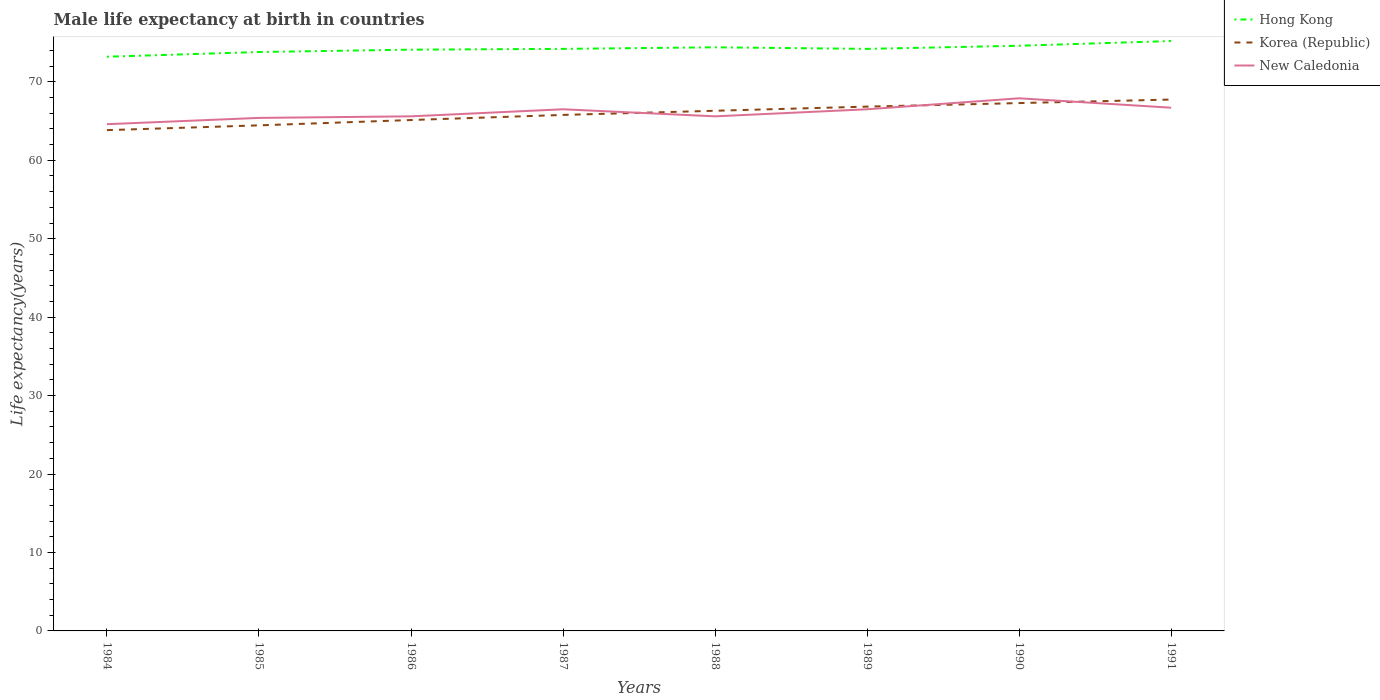How many different coloured lines are there?
Your response must be concise. 3. Across all years, what is the maximum male life expectancy at birth in Korea (Republic)?
Your answer should be very brief. 63.84. In which year was the male life expectancy at birth in New Caledonia maximum?
Your answer should be very brief. 1984. What is the difference between the highest and the second highest male life expectancy at birth in Hong Kong?
Offer a terse response. 2. What is the difference between the highest and the lowest male life expectancy at birth in Korea (Republic)?
Your answer should be compact. 4. Is the male life expectancy at birth in Korea (Republic) strictly greater than the male life expectancy at birth in New Caledonia over the years?
Provide a short and direct response. No. Does the graph contain any zero values?
Give a very brief answer. No. Does the graph contain grids?
Make the answer very short. No. How many legend labels are there?
Keep it short and to the point. 3. What is the title of the graph?
Provide a short and direct response. Male life expectancy at birth in countries. What is the label or title of the Y-axis?
Ensure brevity in your answer.  Life expectancy(years). What is the Life expectancy(years) in Hong Kong in 1984?
Offer a terse response. 73.2. What is the Life expectancy(years) in Korea (Republic) in 1984?
Make the answer very short. 63.84. What is the Life expectancy(years) of New Caledonia in 1984?
Your response must be concise. 64.6. What is the Life expectancy(years) in Hong Kong in 1985?
Ensure brevity in your answer.  73.8. What is the Life expectancy(years) of Korea (Republic) in 1985?
Your answer should be very brief. 64.45. What is the Life expectancy(years) in New Caledonia in 1985?
Make the answer very short. 65.4. What is the Life expectancy(years) in Hong Kong in 1986?
Provide a short and direct response. 74.1. What is the Life expectancy(years) in Korea (Republic) in 1986?
Offer a terse response. 65.13. What is the Life expectancy(years) of New Caledonia in 1986?
Your response must be concise. 65.6. What is the Life expectancy(years) of Hong Kong in 1987?
Offer a terse response. 74.2. What is the Life expectancy(years) in Korea (Republic) in 1987?
Offer a very short reply. 65.78. What is the Life expectancy(years) in New Caledonia in 1987?
Keep it short and to the point. 66.5. What is the Life expectancy(years) in Hong Kong in 1988?
Ensure brevity in your answer.  74.4. What is the Life expectancy(years) in Korea (Republic) in 1988?
Offer a terse response. 66.31. What is the Life expectancy(years) of New Caledonia in 1988?
Offer a very short reply. 65.6. What is the Life expectancy(years) of Hong Kong in 1989?
Give a very brief answer. 74.2. What is the Life expectancy(years) of Korea (Republic) in 1989?
Provide a succinct answer. 66.84. What is the Life expectancy(years) in New Caledonia in 1989?
Offer a very short reply. 66.5. What is the Life expectancy(years) of Hong Kong in 1990?
Give a very brief answer. 74.6. What is the Life expectancy(years) of Korea (Republic) in 1990?
Your response must be concise. 67.29. What is the Life expectancy(years) of New Caledonia in 1990?
Your response must be concise. 67.9. What is the Life expectancy(years) of Hong Kong in 1991?
Offer a terse response. 75.2. What is the Life expectancy(years) in Korea (Republic) in 1991?
Your answer should be very brief. 67.74. What is the Life expectancy(years) in New Caledonia in 1991?
Keep it short and to the point. 66.7. Across all years, what is the maximum Life expectancy(years) of Hong Kong?
Give a very brief answer. 75.2. Across all years, what is the maximum Life expectancy(years) of Korea (Republic)?
Provide a succinct answer. 67.74. Across all years, what is the maximum Life expectancy(years) of New Caledonia?
Offer a terse response. 67.9. Across all years, what is the minimum Life expectancy(years) in Hong Kong?
Keep it short and to the point. 73.2. Across all years, what is the minimum Life expectancy(years) in Korea (Republic)?
Provide a short and direct response. 63.84. Across all years, what is the minimum Life expectancy(years) of New Caledonia?
Provide a short and direct response. 64.6. What is the total Life expectancy(years) in Hong Kong in the graph?
Provide a short and direct response. 593.7. What is the total Life expectancy(years) of Korea (Republic) in the graph?
Offer a terse response. 527.38. What is the total Life expectancy(years) of New Caledonia in the graph?
Keep it short and to the point. 528.8. What is the difference between the Life expectancy(years) in Hong Kong in 1984 and that in 1985?
Provide a succinct answer. -0.6. What is the difference between the Life expectancy(years) of Korea (Republic) in 1984 and that in 1985?
Offer a very short reply. -0.61. What is the difference between the Life expectancy(years) in New Caledonia in 1984 and that in 1985?
Ensure brevity in your answer.  -0.8. What is the difference between the Life expectancy(years) in Korea (Republic) in 1984 and that in 1986?
Your answer should be compact. -1.29. What is the difference between the Life expectancy(years) in Hong Kong in 1984 and that in 1987?
Your answer should be very brief. -1. What is the difference between the Life expectancy(years) in Korea (Republic) in 1984 and that in 1987?
Ensure brevity in your answer.  -1.94. What is the difference between the Life expectancy(years) of Korea (Republic) in 1984 and that in 1988?
Make the answer very short. -2.47. What is the difference between the Life expectancy(years) of Hong Kong in 1984 and that in 1989?
Your response must be concise. -1. What is the difference between the Life expectancy(years) in Korea (Republic) in 1984 and that in 1989?
Give a very brief answer. -3. What is the difference between the Life expectancy(years) of New Caledonia in 1984 and that in 1989?
Offer a very short reply. -1.9. What is the difference between the Life expectancy(years) in Hong Kong in 1984 and that in 1990?
Make the answer very short. -1.4. What is the difference between the Life expectancy(years) in Korea (Republic) in 1984 and that in 1990?
Provide a short and direct response. -3.45. What is the difference between the Life expectancy(years) of Hong Kong in 1984 and that in 1991?
Give a very brief answer. -2. What is the difference between the Life expectancy(years) in Korea (Republic) in 1984 and that in 1991?
Your response must be concise. -3.9. What is the difference between the Life expectancy(years) in New Caledonia in 1984 and that in 1991?
Provide a succinct answer. -2.1. What is the difference between the Life expectancy(years) in Korea (Republic) in 1985 and that in 1986?
Your response must be concise. -0.68. What is the difference between the Life expectancy(years) in Korea (Republic) in 1985 and that in 1987?
Your answer should be very brief. -1.33. What is the difference between the Life expectancy(years) in Hong Kong in 1985 and that in 1988?
Keep it short and to the point. -0.6. What is the difference between the Life expectancy(years) in Korea (Republic) in 1985 and that in 1988?
Make the answer very short. -1.86. What is the difference between the Life expectancy(years) of Korea (Republic) in 1985 and that in 1989?
Offer a very short reply. -2.39. What is the difference between the Life expectancy(years) of Hong Kong in 1985 and that in 1990?
Your answer should be very brief. -0.8. What is the difference between the Life expectancy(years) of Korea (Republic) in 1985 and that in 1990?
Provide a short and direct response. -2.84. What is the difference between the Life expectancy(years) of Hong Kong in 1985 and that in 1991?
Provide a succinct answer. -1.4. What is the difference between the Life expectancy(years) in Korea (Republic) in 1985 and that in 1991?
Provide a short and direct response. -3.29. What is the difference between the Life expectancy(years) of Korea (Republic) in 1986 and that in 1987?
Your response must be concise. -0.65. What is the difference between the Life expectancy(years) in New Caledonia in 1986 and that in 1987?
Your answer should be very brief. -0.9. What is the difference between the Life expectancy(years) in Hong Kong in 1986 and that in 1988?
Your answer should be very brief. -0.3. What is the difference between the Life expectancy(years) in Korea (Republic) in 1986 and that in 1988?
Offer a terse response. -1.18. What is the difference between the Life expectancy(years) of New Caledonia in 1986 and that in 1988?
Keep it short and to the point. 0. What is the difference between the Life expectancy(years) in Korea (Republic) in 1986 and that in 1989?
Keep it short and to the point. -1.71. What is the difference between the Life expectancy(years) of Korea (Republic) in 1986 and that in 1990?
Provide a short and direct response. -2.16. What is the difference between the Life expectancy(years) in Korea (Republic) in 1986 and that in 1991?
Ensure brevity in your answer.  -2.61. What is the difference between the Life expectancy(years) of New Caledonia in 1986 and that in 1991?
Provide a succinct answer. -1.1. What is the difference between the Life expectancy(years) of Hong Kong in 1987 and that in 1988?
Provide a short and direct response. -0.2. What is the difference between the Life expectancy(years) in Korea (Republic) in 1987 and that in 1988?
Provide a succinct answer. -0.53. What is the difference between the Life expectancy(years) in Korea (Republic) in 1987 and that in 1989?
Give a very brief answer. -1.06. What is the difference between the Life expectancy(years) in Korea (Republic) in 1987 and that in 1990?
Offer a very short reply. -1.51. What is the difference between the Life expectancy(years) in Hong Kong in 1987 and that in 1991?
Your answer should be very brief. -1. What is the difference between the Life expectancy(years) of Korea (Republic) in 1987 and that in 1991?
Your answer should be very brief. -1.96. What is the difference between the Life expectancy(years) in New Caledonia in 1987 and that in 1991?
Give a very brief answer. -0.2. What is the difference between the Life expectancy(years) of Korea (Republic) in 1988 and that in 1989?
Provide a succinct answer. -0.53. What is the difference between the Life expectancy(years) of Hong Kong in 1988 and that in 1990?
Your answer should be very brief. -0.2. What is the difference between the Life expectancy(years) of Korea (Republic) in 1988 and that in 1990?
Offer a terse response. -0.98. What is the difference between the Life expectancy(years) of Korea (Republic) in 1988 and that in 1991?
Ensure brevity in your answer.  -1.43. What is the difference between the Life expectancy(years) in Hong Kong in 1989 and that in 1990?
Your answer should be compact. -0.4. What is the difference between the Life expectancy(years) in Korea (Republic) in 1989 and that in 1990?
Your response must be concise. -0.45. What is the difference between the Life expectancy(years) of New Caledonia in 1989 and that in 1990?
Make the answer very short. -1.4. What is the difference between the Life expectancy(years) of Hong Kong in 1989 and that in 1991?
Your response must be concise. -1. What is the difference between the Life expectancy(years) in Korea (Republic) in 1990 and that in 1991?
Make the answer very short. -0.45. What is the difference between the Life expectancy(years) in New Caledonia in 1990 and that in 1991?
Give a very brief answer. 1.2. What is the difference between the Life expectancy(years) in Hong Kong in 1984 and the Life expectancy(years) in Korea (Republic) in 1985?
Provide a short and direct response. 8.75. What is the difference between the Life expectancy(years) in Korea (Republic) in 1984 and the Life expectancy(years) in New Caledonia in 1985?
Offer a very short reply. -1.56. What is the difference between the Life expectancy(years) of Hong Kong in 1984 and the Life expectancy(years) of Korea (Republic) in 1986?
Give a very brief answer. 8.07. What is the difference between the Life expectancy(years) of Hong Kong in 1984 and the Life expectancy(years) of New Caledonia in 1986?
Give a very brief answer. 7.6. What is the difference between the Life expectancy(years) in Korea (Republic) in 1984 and the Life expectancy(years) in New Caledonia in 1986?
Offer a very short reply. -1.76. What is the difference between the Life expectancy(years) in Hong Kong in 1984 and the Life expectancy(years) in Korea (Republic) in 1987?
Offer a terse response. 7.42. What is the difference between the Life expectancy(years) in Hong Kong in 1984 and the Life expectancy(years) in New Caledonia in 1987?
Offer a very short reply. 6.7. What is the difference between the Life expectancy(years) in Korea (Republic) in 1984 and the Life expectancy(years) in New Caledonia in 1987?
Keep it short and to the point. -2.66. What is the difference between the Life expectancy(years) in Hong Kong in 1984 and the Life expectancy(years) in Korea (Republic) in 1988?
Ensure brevity in your answer.  6.89. What is the difference between the Life expectancy(years) of Hong Kong in 1984 and the Life expectancy(years) of New Caledonia in 1988?
Provide a short and direct response. 7.6. What is the difference between the Life expectancy(years) of Korea (Republic) in 1984 and the Life expectancy(years) of New Caledonia in 1988?
Provide a short and direct response. -1.76. What is the difference between the Life expectancy(years) in Hong Kong in 1984 and the Life expectancy(years) in Korea (Republic) in 1989?
Offer a very short reply. 6.36. What is the difference between the Life expectancy(years) of Hong Kong in 1984 and the Life expectancy(years) of New Caledonia in 1989?
Give a very brief answer. 6.7. What is the difference between the Life expectancy(years) in Korea (Republic) in 1984 and the Life expectancy(years) in New Caledonia in 1989?
Your answer should be very brief. -2.66. What is the difference between the Life expectancy(years) in Hong Kong in 1984 and the Life expectancy(years) in Korea (Republic) in 1990?
Make the answer very short. 5.91. What is the difference between the Life expectancy(years) of Korea (Republic) in 1984 and the Life expectancy(years) of New Caledonia in 1990?
Make the answer very short. -4.06. What is the difference between the Life expectancy(years) of Hong Kong in 1984 and the Life expectancy(years) of Korea (Republic) in 1991?
Make the answer very short. 5.46. What is the difference between the Life expectancy(years) of Korea (Republic) in 1984 and the Life expectancy(years) of New Caledonia in 1991?
Offer a terse response. -2.86. What is the difference between the Life expectancy(years) in Hong Kong in 1985 and the Life expectancy(years) in Korea (Republic) in 1986?
Offer a terse response. 8.67. What is the difference between the Life expectancy(years) in Korea (Republic) in 1985 and the Life expectancy(years) in New Caledonia in 1986?
Provide a short and direct response. -1.15. What is the difference between the Life expectancy(years) in Hong Kong in 1985 and the Life expectancy(years) in Korea (Republic) in 1987?
Make the answer very short. 8.02. What is the difference between the Life expectancy(years) in Hong Kong in 1985 and the Life expectancy(years) in New Caledonia in 1987?
Give a very brief answer. 7.3. What is the difference between the Life expectancy(years) of Korea (Republic) in 1985 and the Life expectancy(years) of New Caledonia in 1987?
Give a very brief answer. -2.05. What is the difference between the Life expectancy(years) in Hong Kong in 1985 and the Life expectancy(years) in Korea (Republic) in 1988?
Make the answer very short. 7.49. What is the difference between the Life expectancy(years) in Hong Kong in 1985 and the Life expectancy(years) in New Caledonia in 1988?
Keep it short and to the point. 8.2. What is the difference between the Life expectancy(years) in Korea (Republic) in 1985 and the Life expectancy(years) in New Caledonia in 1988?
Offer a very short reply. -1.15. What is the difference between the Life expectancy(years) in Hong Kong in 1985 and the Life expectancy(years) in Korea (Republic) in 1989?
Keep it short and to the point. 6.96. What is the difference between the Life expectancy(years) in Korea (Republic) in 1985 and the Life expectancy(years) in New Caledonia in 1989?
Make the answer very short. -2.05. What is the difference between the Life expectancy(years) in Hong Kong in 1985 and the Life expectancy(years) in Korea (Republic) in 1990?
Your response must be concise. 6.51. What is the difference between the Life expectancy(years) in Korea (Republic) in 1985 and the Life expectancy(years) in New Caledonia in 1990?
Give a very brief answer. -3.45. What is the difference between the Life expectancy(years) in Hong Kong in 1985 and the Life expectancy(years) in Korea (Republic) in 1991?
Offer a terse response. 6.06. What is the difference between the Life expectancy(years) in Hong Kong in 1985 and the Life expectancy(years) in New Caledonia in 1991?
Provide a short and direct response. 7.1. What is the difference between the Life expectancy(years) in Korea (Republic) in 1985 and the Life expectancy(years) in New Caledonia in 1991?
Your answer should be very brief. -2.25. What is the difference between the Life expectancy(years) in Hong Kong in 1986 and the Life expectancy(years) in Korea (Republic) in 1987?
Provide a succinct answer. 8.32. What is the difference between the Life expectancy(years) of Korea (Republic) in 1986 and the Life expectancy(years) of New Caledonia in 1987?
Your answer should be very brief. -1.37. What is the difference between the Life expectancy(years) in Hong Kong in 1986 and the Life expectancy(years) in Korea (Republic) in 1988?
Provide a succinct answer. 7.79. What is the difference between the Life expectancy(years) in Korea (Republic) in 1986 and the Life expectancy(years) in New Caledonia in 1988?
Your answer should be very brief. -0.47. What is the difference between the Life expectancy(years) in Hong Kong in 1986 and the Life expectancy(years) in Korea (Republic) in 1989?
Ensure brevity in your answer.  7.26. What is the difference between the Life expectancy(years) in Korea (Republic) in 1986 and the Life expectancy(years) in New Caledonia in 1989?
Give a very brief answer. -1.37. What is the difference between the Life expectancy(years) of Hong Kong in 1986 and the Life expectancy(years) of Korea (Republic) in 1990?
Your answer should be very brief. 6.81. What is the difference between the Life expectancy(years) in Hong Kong in 1986 and the Life expectancy(years) in New Caledonia in 1990?
Offer a very short reply. 6.2. What is the difference between the Life expectancy(years) in Korea (Republic) in 1986 and the Life expectancy(years) in New Caledonia in 1990?
Provide a short and direct response. -2.77. What is the difference between the Life expectancy(years) of Hong Kong in 1986 and the Life expectancy(years) of Korea (Republic) in 1991?
Your answer should be very brief. 6.36. What is the difference between the Life expectancy(years) in Korea (Republic) in 1986 and the Life expectancy(years) in New Caledonia in 1991?
Provide a short and direct response. -1.57. What is the difference between the Life expectancy(years) of Hong Kong in 1987 and the Life expectancy(years) of Korea (Republic) in 1988?
Provide a succinct answer. 7.89. What is the difference between the Life expectancy(years) of Korea (Republic) in 1987 and the Life expectancy(years) of New Caledonia in 1988?
Provide a short and direct response. 0.18. What is the difference between the Life expectancy(years) in Hong Kong in 1987 and the Life expectancy(years) in Korea (Republic) in 1989?
Your response must be concise. 7.36. What is the difference between the Life expectancy(years) of Hong Kong in 1987 and the Life expectancy(years) of New Caledonia in 1989?
Offer a very short reply. 7.7. What is the difference between the Life expectancy(years) of Korea (Republic) in 1987 and the Life expectancy(years) of New Caledonia in 1989?
Your answer should be very brief. -0.72. What is the difference between the Life expectancy(years) of Hong Kong in 1987 and the Life expectancy(years) of Korea (Republic) in 1990?
Ensure brevity in your answer.  6.91. What is the difference between the Life expectancy(years) in Korea (Republic) in 1987 and the Life expectancy(years) in New Caledonia in 1990?
Your answer should be compact. -2.12. What is the difference between the Life expectancy(years) in Hong Kong in 1987 and the Life expectancy(years) in Korea (Republic) in 1991?
Provide a succinct answer. 6.46. What is the difference between the Life expectancy(years) of Korea (Republic) in 1987 and the Life expectancy(years) of New Caledonia in 1991?
Keep it short and to the point. -0.92. What is the difference between the Life expectancy(years) in Hong Kong in 1988 and the Life expectancy(years) in Korea (Republic) in 1989?
Offer a very short reply. 7.56. What is the difference between the Life expectancy(years) of Korea (Republic) in 1988 and the Life expectancy(years) of New Caledonia in 1989?
Your answer should be very brief. -0.19. What is the difference between the Life expectancy(years) of Hong Kong in 1988 and the Life expectancy(years) of Korea (Republic) in 1990?
Provide a succinct answer. 7.11. What is the difference between the Life expectancy(years) of Hong Kong in 1988 and the Life expectancy(years) of New Caledonia in 1990?
Keep it short and to the point. 6.5. What is the difference between the Life expectancy(years) of Korea (Republic) in 1988 and the Life expectancy(years) of New Caledonia in 1990?
Provide a short and direct response. -1.59. What is the difference between the Life expectancy(years) in Hong Kong in 1988 and the Life expectancy(years) in Korea (Republic) in 1991?
Keep it short and to the point. 6.66. What is the difference between the Life expectancy(years) of Korea (Republic) in 1988 and the Life expectancy(years) of New Caledonia in 1991?
Ensure brevity in your answer.  -0.39. What is the difference between the Life expectancy(years) in Hong Kong in 1989 and the Life expectancy(years) in Korea (Republic) in 1990?
Keep it short and to the point. 6.91. What is the difference between the Life expectancy(years) of Hong Kong in 1989 and the Life expectancy(years) of New Caledonia in 1990?
Offer a terse response. 6.3. What is the difference between the Life expectancy(years) of Korea (Republic) in 1989 and the Life expectancy(years) of New Caledonia in 1990?
Your answer should be compact. -1.06. What is the difference between the Life expectancy(years) in Hong Kong in 1989 and the Life expectancy(years) in Korea (Republic) in 1991?
Provide a succinct answer. 6.46. What is the difference between the Life expectancy(years) of Hong Kong in 1989 and the Life expectancy(years) of New Caledonia in 1991?
Keep it short and to the point. 7.5. What is the difference between the Life expectancy(years) of Korea (Republic) in 1989 and the Life expectancy(years) of New Caledonia in 1991?
Provide a succinct answer. 0.14. What is the difference between the Life expectancy(years) in Hong Kong in 1990 and the Life expectancy(years) in Korea (Republic) in 1991?
Offer a very short reply. 6.86. What is the difference between the Life expectancy(years) of Hong Kong in 1990 and the Life expectancy(years) of New Caledonia in 1991?
Your response must be concise. 7.9. What is the difference between the Life expectancy(years) of Korea (Republic) in 1990 and the Life expectancy(years) of New Caledonia in 1991?
Provide a short and direct response. 0.59. What is the average Life expectancy(years) in Hong Kong per year?
Ensure brevity in your answer.  74.21. What is the average Life expectancy(years) of Korea (Republic) per year?
Keep it short and to the point. 65.92. What is the average Life expectancy(years) of New Caledonia per year?
Your response must be concise. 66.1. In the year 1984, what is the difference between the Life expectancy(years) of Hong Kong and Life expectancy(years) of Korea (Republic)?
Ensure brevity in your answer.  9.36. In the year 1984, what is the difference between the Life expectancy(years) in Hong Kong and Life expectancy(years) in New Caledonia?
Offer a terse response. 8.6. In the year 1984, what is the difference between the Life expectancy(years) of Korea (Republic) and Life expectancy(years) of New Caledonia?
Ensure brevity in your answer.  -0.76. In the year 1985, what is the difference between the Life expectancy(years) in Hong Kong and Life expectancy(years) in Korea (Republic)?
Keep it short and to the point. 9.35. In the year 1985, what is the difference between the Life expectancy(years) in Korea (Republic) and Life expectancy(years) in New Caledonia?
Offer a very short reply. -0.95. In the year 1986, what is the difference between the Life expectancy(years) in Hong Kong and Life expectancy(years) in Korea (Republic)?
Provide a short and direct response. 8.97. In the year 1986, what is the difference between the Life expectancy(years) in Korea (Republic) and Life expectancy(years) in New Caledonia?
Make the answer very short. -0.47. In the year 1987, what is the difference between the Life expectancy(years) in Hong Kong and Life expectancy(years) in Korea (Republic)?
Give a very brief answer. 8.42. In the year 1987, what is the difference between the Life expectancy(years) in Hong Kong and Life expectancy(years) in New Caledonia?
Provide a succinct answer. 7.7. In the year 1987, what is the difference between the Life expectancy(years) of Korea (Republic) and Life expectancy(years) of New Caledonia?
Keep it short and to the point. -0.72. In the year 1988, what is the difference between the Life expectancy(years) of Hong Kong and Life expectancy(years) of Korea (Republic)?
Give a very brief answer. 8.09. In the year 1988, what is the difference between the Life expectancy(years) in Hong Kong and Life expectancy(years) in New Caledonia?
Offer a very short reply. 8.8. In the year 1988, what is the difference between the Life expectancy(years) of Korea (Republic) and Life expectancy(years) of New Caledonia?
Give a very brief answer. 0.71. In the year 1989, what is the difference between the Life expectancy(years) of Hong Kong and Life expectancy(years) of Korea (Republic)?
Provide a succinct answer. 7.36. In the year 1989, what is the difference between the Life expectancy(years) in Hong Kong and Life expectancy(years) in New Caledonia?
Offer a very short reply. 7.7. In the year 1989, what is the difference between the Life expectancy(years) of Korea (Republic) and Life expectancy(years) of New Caledonia?
Make the answer very short. 0.34. In the year 1990, what is the difference between the Life expectancy(years) of Hong Kong and Life expectancy(years) of Korea (Republic)?
Your response must be concise. 7.31. In the year 1990, what is the difference between the Life expectancy(years) of Hong Kong and Life expectancy(years) of New Caledonia?
Ensure brevity in your answer.  6.7. In the year 1990, what is the difference between the Life expectancy(years) in Korea (Republic) and Life expectancy(years) in New Caledonia?
Ensure brevity in your answer.  -0.61. In the year 1991, what is the difference between the Life expectancy(years) of Hong Kong and Life expectancy(years) of Korea (Republic)?
Offer a very short reply. 7.46. In the year 1991, what is the difference between the Life expectancy(years) of Hong Kong and Life expectancy(years) of New Caledonia?
Offer a terse response. 8.5. In the year 1991, what is the difference between the Life expectancy(years) of Korea (Republic) and Life expectancy(years) of New Caledonia?
Give a very brief answer. 1.04. What is the ratio of the Life expectancy(years) in Hong Kong in 1984 to that in 1986?
Your answer should be very brief. 0.99. What is the ratio of the Life expectancy(years) of Korea (Republic) in 1984 to that in 1986?
Offer a terse response. 0.98. What is the ratio of the Life expectancy(years) of New Caledonia in 1984 to that in 1986?
Your answer should be compact. 0.98. What is the ratio of the Life expectancy(years) of Hong Kong in 1984 to that in 1987?
Provide a short and direct response. 0.99. What is the ratio of the Life expectancy(years) in Korea (Republic) in 1984 to that in 1987?
Make the answer very short. 0.97. What is the ratio of the Life expectancy(years) of New Caledonia in 1984 to that in 1987?
Your response must be concise. 0.97. What is the ratio of the Life expectancy(years) of Hong Kong in 1984 to that in 1988?
Your response must be concise. 0.98. What is the ratio of the Life expectancy(years) of Korea (Republic) in 1984 to that in 1988?
Keep it short and to the point. 0.96. What is the ratio of the Life expectancy(years) of Hong Kong in 1984 to that in 1989?
Make the answer very short. 0.99. What is the ratio of the Life expectancy(years) of Korea (Republic) in 1984 to that in 1989?
Your answer should be very brief. 0.96. What is the ratio of the Life expectancy(years) of New Caledonia in 1984 to that in 1989?
Your response must be concise. 0.97. What is the ratio of the Life expectancy(years) of Hong Kong in 1984 to that in 1990?
Provide a short and direct response. 0.98. What is the ratio of the Life expectancy(years) in Korea (Republic) in 1984 to that in 1990?
Your answer should be compact. 0.95. What is the ratio of the Life expectancy(years) in New Caledonia in 1984 to that in 1990?
Ensure brevity in your answer.  0.95. What is the ratio of the Life expectancy(years) in Hong Kong in 1984 to that in 1991?
Your answer should be very brief. 0.97. What is the ratio of the Life expectancy(years) of Korea (Republic) in 1984 to that in 1991?
Provide a short and direct response. 0.94. What is the ratio of the Life expectancy(years) in New Caledonia in 1984 to that in 1991?
Provide a short and direct response. 0.97. What is the ratio of the Life expectancy(years) in Korea (Republic) in 1985 to that in 1986?
Provide a succinct answer. 0.99. What is the ratio of the Life expectancy(years) of New Caledonia in 1985 to that in 1986?
Keep it short and to the point. 1. What is the ratio of the Life expectancy(years) of Korea (Republic) in 1985 to that in 1987?
Ensure brevity in your answer.  0.98. What is the ratio of the Life expectancy(years) in New Caledonia in 1985 to that in 1987?
Give a very brief answer. 0.98. What is the ratio of the Life expectancy(years) of Hong Kong in 1985 to that in 1988?
Your answer should be compact. 0.99. What is the ratio of the Life expectancy(years) of Korea (Republic) in 1985 to that in 1988?
Offer a very short reply. 0.97. What is the ratio of the Life expectancy(years) of Hong Kong in 1985 to that in 1989?
Provide a succinct answer. 0.99. What is the ratio of the Life expectancy(years) of Korea (Republic) in 1985 to that in 1989?
Provide a succinct answer. 0.96. What is the ratio of the Life expectancy(years) in New Caledonia in 1985 to that in 1989?
Keep it short and to the point. 0.98. What is the ratio of the Life expectancy(years) of Hong Kong in 1985 to that in 1990?
Your answer should be very brief. 0.99. What is the ratio of the Life expectancy(years) in Korea (Republic) in 1985 to that in 1990?
Provide a short and direct response. 0.96. What is the ratio of the Life expectancy(years) in New Caledonia in 1985 to that in 1990?
Keep it short and to the point. 0.96. What is the ratio of the Life expectancy(years) in Hong Kong in 1985 to that in 1991?
Your answer should be compact. 0.98. What is the ratio of the Life expectancy(years) of Korea (Republic) in 1985 to that in 1991?
Offer a terse response. 0.95. What is the ratio of the Life expectancy(years) in New Caledonia in 1985 to that in 1991?
Your response must be concise. 0.98. What is the ratio of the Life expectancy(years) in New Caledonia in 1986 to that in 1987?
Provide a succinct answer. 0.99. What is the ratio of the Life expectancy(years) in Korea (Republic) in 1986 to that in 1988?
Provide a short and direct response. 0.98. What is the ratio of the Life expectancy(years) in Korea (Republic) in 1986 to that in 1989?
Your response must be concise. 0.97. What is the ratio of the Life expectancy(years) in New Caledonia in 1986 to that in 1989?
Offer a very short reply. 0.99. What is the ratio of the Life expectancy(years) of Hong Kong in 1986 to that in 1990?
Provide a succinct answer. 0.99. What is the ratio of the Life expectancy(years) in Korea (Republic) in 1986 to that in 1990?
Make the answer very short. 0.97. What is the ratio of the Life expectancy(years) in New Caledonia in 1986 to that in 1990?
Your answer should be compact. 0.97. What is the ratio of the Life expectancy(years) of Hong Kong in 1986 to that in 1991?
Provide a succinct answer. 0.99. What is the ratio of the Life expectancy(years) of Korea (Republic) in 1986 to that in 1991?
Keep it short and to the point. 0.96. What is the ratio of the Life expectancy(years) of New Caledonia in 1986 to that in 1991?
Your answer should be very brief. 0.98. What is the ratio of the Life expectancy(years) of Hong Kong in 1987 to that in 1988?
Give a very brief answer. 1. What is the ratio of the Life expectancy(years) in Korea (Republic) in 1987 to that in 1988?
Your answer should be very brief. 0.99. What is the ratio of the Life expectancy(years) in New Caledonia in 1987 to that in 1988?
Your response must be concise. 1.01. What is the ratio of the Life expectancy(years) of Korea (Republic) in 1987 to that in 1989?
Provide a short and direct response. 0.98. What is the ratio of the Life expectancy(years) in New Caledonia in 1987 to that in 1989?
Ensure brevity in your answer.  1. What is the ratio of the Life expectancy(years) in Korea (Republic) in 1987 to that in 1990?
Your answer should be compact. 0.98. What is the ratio of the Life expectancy(years) of New Caledonia in 1987 to that in 1990?
Your response must be concise. 0.98. What is the ratio of the Life expectancy(years) of Hong Kong in 1987 to that in 1991?
Offer a terse response. 0.99. What is the ratio of the Life expectancy(years) in Korea (Republic) in 1987 to that in 1991?
Give a very brief answer. 0.97. What is the ratio of the Life expectancy(years) in New Caledonia in 1987 to that in 1991?
Make the answer very short. 1. What is the ratio of the Life expectancy(years) in Hong Kong in 1988 to that in 1989?
Ensure brevity in your answer.  1. What is the ratio of the Life expectancy(years) in New Caledonia in 1988 to that in 1989?
Provide a succinct answer. 0.99. What is the ratio of the Life expectancy(years) of Korea (Republic) in 1988 to that in 1990?
Your answer should be very brief. 0.99. What is the ratio of the Life expectancy(years) in New Caledonia in 1988 to that in 1990?
Provide a short and direct response. 0.97. What is the ratio of the Life expectancy(years) in Korea (Republic) in 1988 to that in 1991?
Keep it short and to the point. 0.98. What is the ratio of the Life expectancy(years) of New Caledonia in 1988 to that in 1991?
Offer a terse response. 0.98. What is the ratio of the Life expectancy(years) in Hong Kong in 1989 to that in 1990?
Ensure brevity in your answer.  0.99. What is the ratio of the Life expectancy(years) of Korea (Republic) in 1989 to that in 1990?
Provide a succinct answer. 0.99. What is the ratio of the Life expectancy(years) of New Caledonia in 1989 to that in 1990?
Offer a very short reply. 0.98. What is the ratio of the Life expectancy(years) in Hong Kong in 1989 to that in 1991?
Provide a short and direct response. 0.99. What is the ratio of the Life expectancy(years) of Korea (Republic) in 1989 to that in 1991?
Make the answer very short. 0.99. What is the ratio of the Life expectancy(years) of New Caledonia in 1990 to that in 1991?
Ensure brevity in your answer.  1.02. What is the difference between the highest and the second highest Life expectancy(years) of Hong Kong?
Ensure brevity in your answer.  0.6. What is the difference between the highest and the second highest Life expectancy(years) of Korea (Republic)?
Provide a succinct answer. 0.45. What is the difference between the highest and the second highest Life expectancy(years) of New Caledonia?
Your answer should be compact. 1.2. 